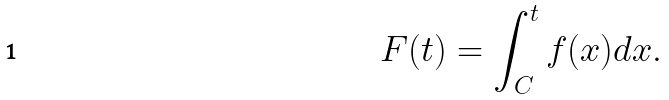Convert formula to latex. <formula><loc_0><loc_0><loc_500><loc_500>F ( t ) = \int _ { C } ^ { t } f ( x ) d x .</formula> 